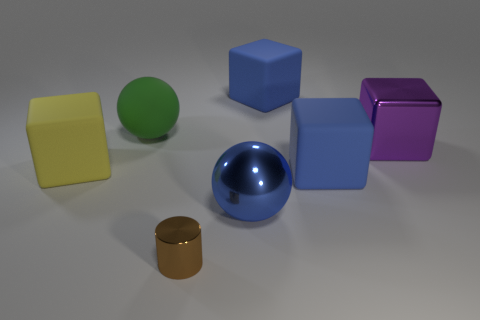Subtract 1 cubes. How many cubes are left? 3 Add 1 blue matte blocks. How many objects exist? 8 Subtract all cylinders. How many objects are left? 6 Add 5 blue things. How many blue things are left? 8 Add 5 small gray rubber spheres. How many small gray rubber spheres exist? 5 Subtract 1 blue spheres. How many objects are left? 6 Subtract all large blue blocks. Subtract all shiny spheres. How many objects are left? 4 